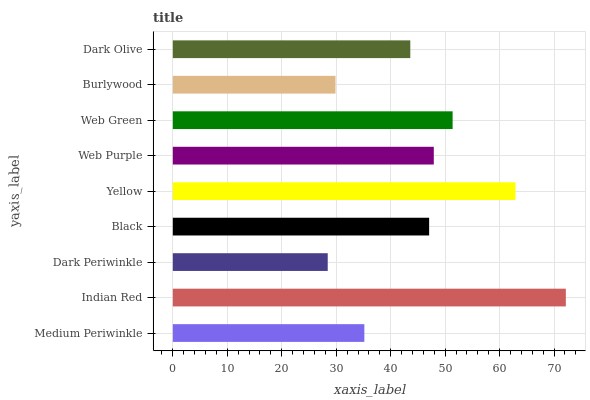Is Dark Periwinkle the minimum?
Answer yes or no. Yes. Is Indian Red the maximum?
Answer yes or no. Yes. Is Indian Red the minimum?
Answer yes or no. No. Is Dark Periwinkle the maximum?
Answer yes or no. No. Is Indian Red greater than Dark Periwinkle?
Answer yes or no. Yes. Is Dark Periwinkle less than Indian Red?
Answer yes or no. Yes. Is Dark Periwinkle greater than Indian Red?
Answer yes or no. No. Is Indian Red less than Dark Periwinkle?
Answer yes or no. No. Is Black the high median?
Answer yes or no. Yes. Is Black the low median?
Answer yes or no. Yes. Is Web Green the high median?
Answer yes or no. No. Is Yellow the low median?
Answer yes or no. No. 